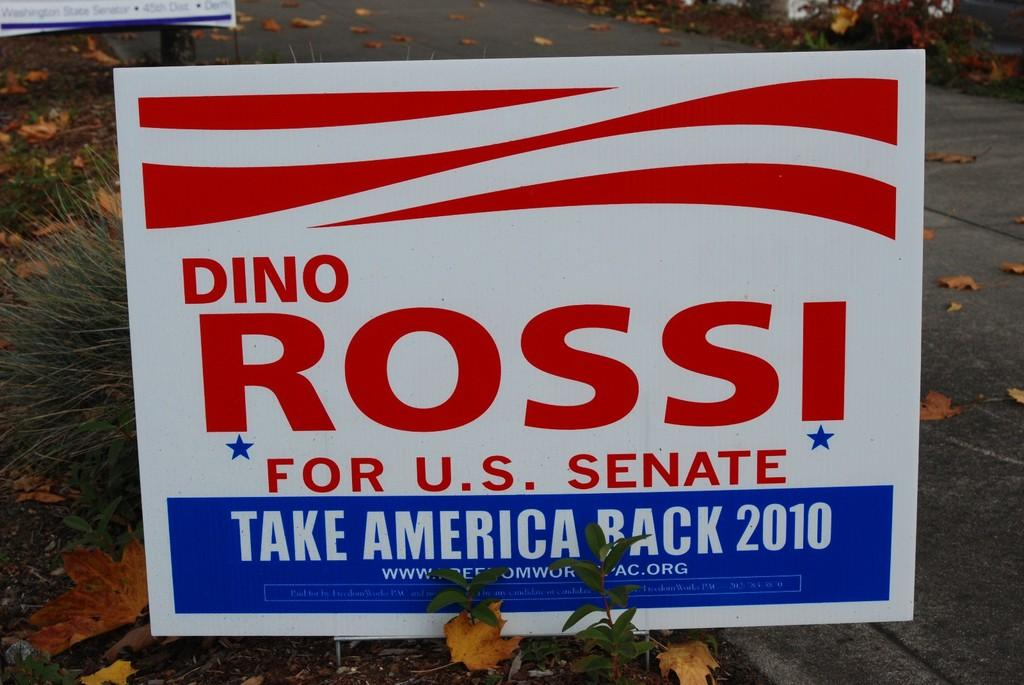Provide a one-sentence caption for the provided image. Advertisement on the street that ass for people to vote for Dino Rossi. 